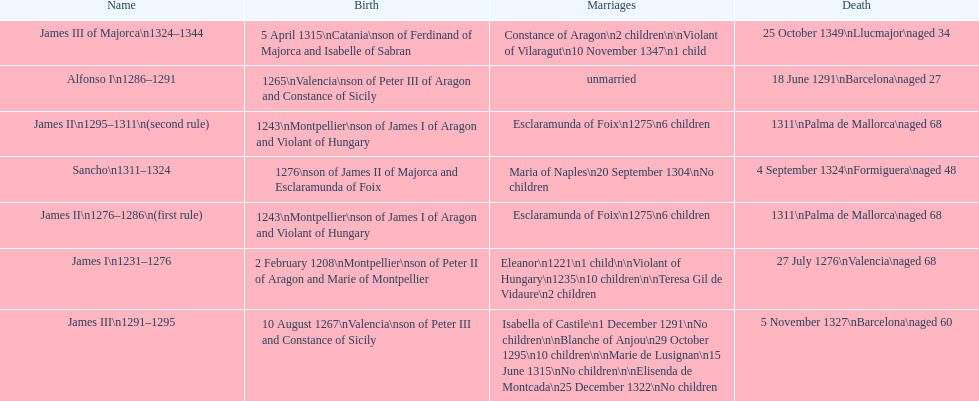How many total marriages did james i have? 3. 